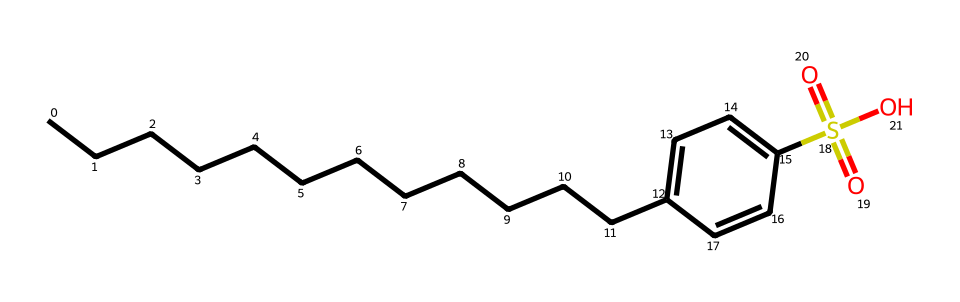What is the name of this chemical? The provided SMILES indicates a compound with a linear alkyl chain and a sulfonate group, specifically linear alkylbenzene sulfonate, which is a common type of surfactant used in detergents.
Answer: linear alkylbenzene sulfonate How many carbon atoms are in the alkyl chain? The linear alkyl chain represented by "CCCCCCCCCCCCC" contains 13 carbon atoms, counting each "C" in the sequence.
Answer: 13 What functional group is present in this structure? The presence of "S(=O)(=O)O" indicates a sulfonate functional group, characterized by a sulfur atom bonded to oxygen atoms with double bonds and a hydroxyl group.
Answer: sulfonate What is the purpose of the sulfonate group in detergents? The sulfonate group serves as the anionic part of the surfactant, which helps to reduce surface tension and enhance cleaning by allowing water to penetrate and remove dirt.
Answer: reduce surface tension Which part of the molecule is hydrophobic? The long carbon chain (CCCCCCCCCCCCC) is hydrophobic due to its nonpolar properties, while the sulfonate group is hydrophilic, allowing the molecule to act as a surfactant.
Answer: long carbon chain What type of chemical is this compound primarily classified as? Given its structure and function in laundry detergents, it is classified as an anionic surfactant, specifically a surfactant that carries a negative charge in solution.
Answer: anionic surfactant How many bonds are present between the sulfur and oxygen atoms in the sulfonate group? In the sulfonate group "S(=O)(=O)O", there are three bonds — two double bonds to oxygen and one single bond to a hydroxyl group.
Answer: three 